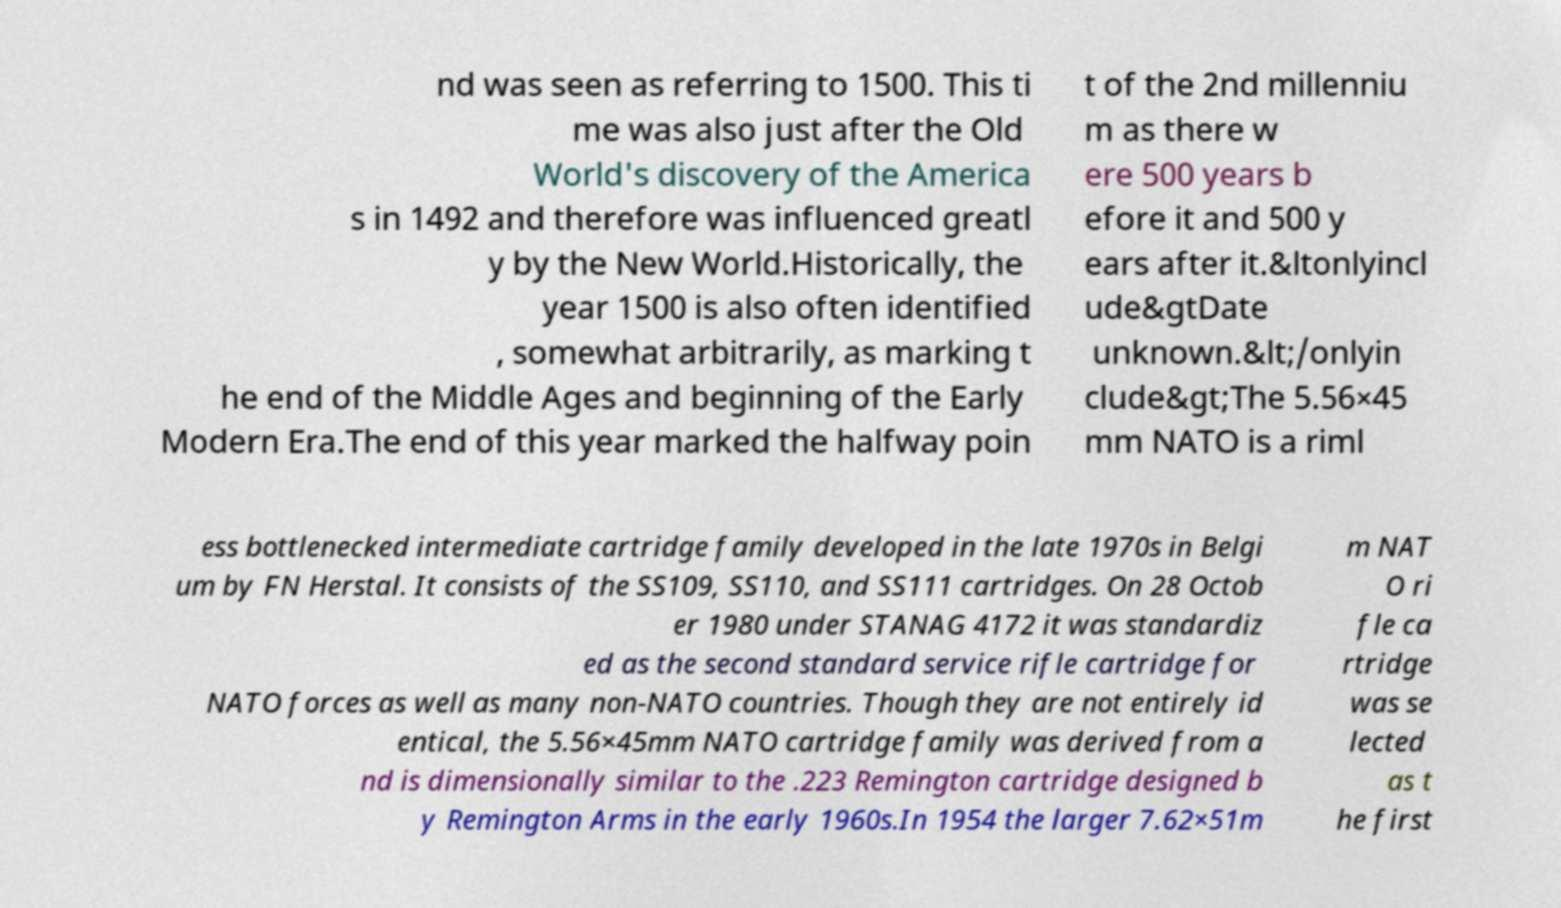Can you read and provide the text displayed in the image?This photo seems to have some interesting text. Can you extract and type it out for me? nd was seen as referring to 1500. This ti me was also just after the Old World's discovery of the America s in 1492 and therefore was influenced greatl y by the New World.Historically, the year 1500 is also often identified , somewhat arbitrarily, as marking t he end of the Middle Ages and beginning of the Early Modern Era.The end of this year marked the halfway poin t of the 2nd millenniu m as there w ere 500 years b efore it and 500 y ears after it.&ltonlyincl ude&gtDate unknown.&lt;/onlyin clude&gt;The 5.56×45 mm NATO is a riml ess bottlenecked intermediate cartridge family developed in the late 1970s in Belgi um by FN Herstal. It consists of the SS109, SS110, and SS111 cartridges. On 28 Octob er 1980 under STANAG 4172 it was standardiz ed as the second standard service rifle cartridge for NATO forces as well as many non-NATO countries. Though they are not entirely id entical, the 5.56×45mm NATO cartridge family was derived from a nd is dimensionally similar to the .223 Remington cartridge designed b y Remington Arms in the early 1960s.In 1954 the larger 7.62×51m m NAT O ri fle ca rtridge was se lected as t he first 